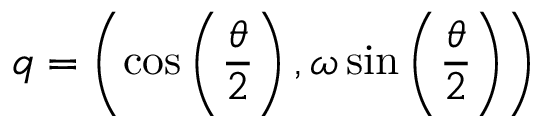Convert formula to latex. <formula><loc_0><loc_0><loc_500><loc_500>q = \left ( \cos \left ( { \frac { \theta } { 2 } } \right ) , \omega \sin \left ( { \frac { \theta } { 2 } } \right ) \right )</formula> 